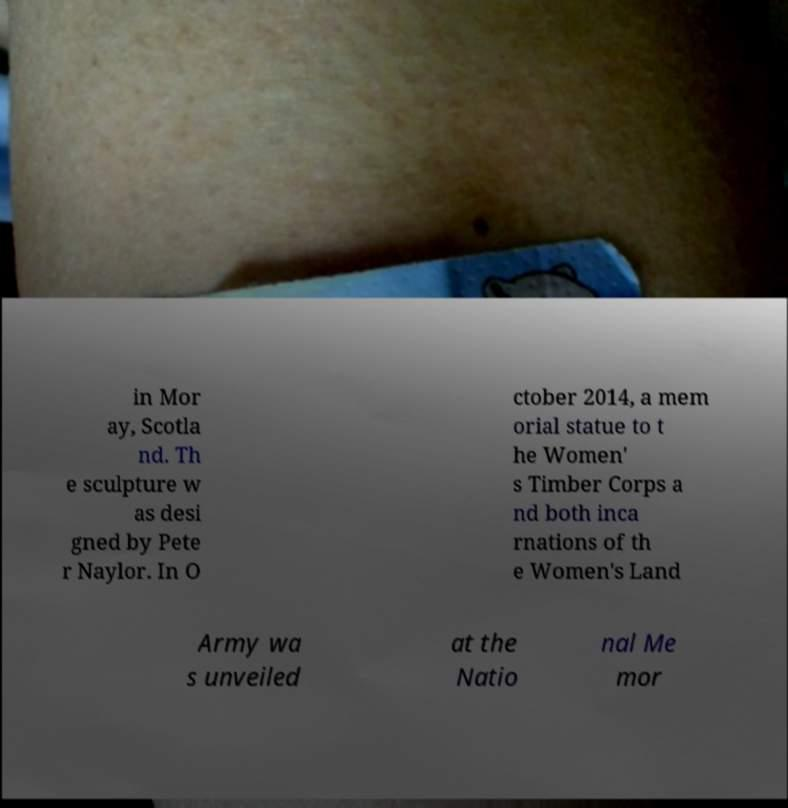Could you extract and type out the text from this image? in Mor ay, Scotla nd. Th e sculpture w as desi gned by Pete r Naylor. In O ctober 2014, a mem orial statue to t he Women' s Timber Corps a nd both inca rnations of th e Women's Land Army wa s unveiled at the Natio nal Me mor 